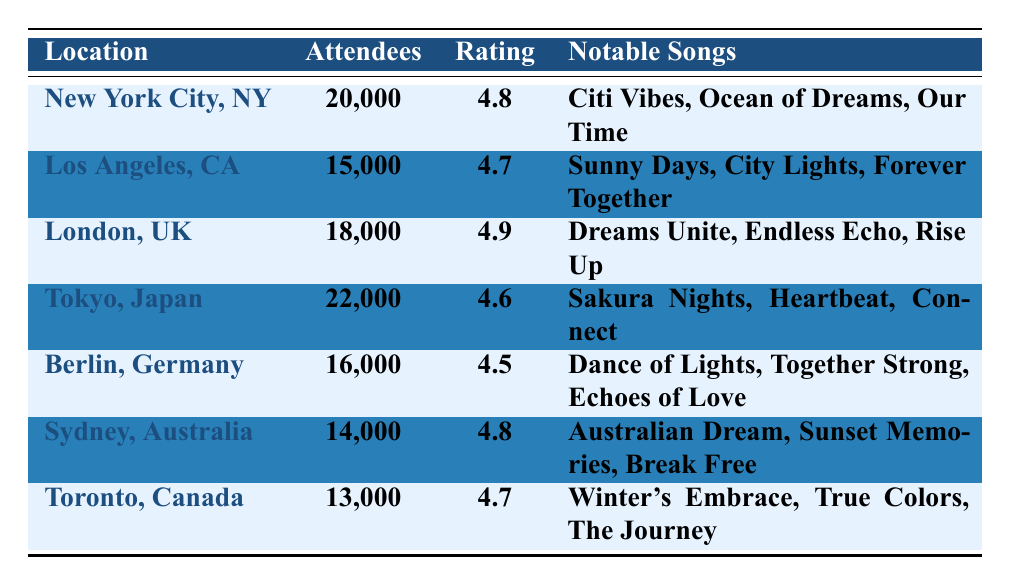What is the highest number of attendees recorded at the concerts? The concert in Tokyo, Japan had the highest number of attendees with 22,000 people.
Answer: 22,000 Which location had the lowest average rating from attendees? The concert in Berlin, Germany had the lowest average rating at 4.5.
Answer: 4.5 What is the total number of attendees across all locations? We add the attendees from each location: 20,000 + 15,000 + 18,000 + 22,000 + 16,000 + 14,000 + 13,000 = 118,000.
Answer: 118,000 Did the concert in London receive the highest average rating? No, the concert in London had a rating of 4.9, but the concert in London did not have the highest; Tokyo's average rating was 4.6 and higher than that of Berlin.
Answer: No Which notable song was performed in both New York City and Los Angeles? The notable song “City Lights” was performed in Los Angeles, while “Citi Vibes” was performed in New York City; therefore, there are no songs performed in both.
Answer: No What is the average number of attendees across all locations? We calculate the average by dividing the total number of attendees (118,000) by the number of locations (7): 118,000 / 7 = 16,857.
Answer: 16,857 How many songs were listed as notable songs for each concert location? Each concert location has exactly 3 notable songs listed.
Answer: 3 Which city's concert had a comment emphasizing "fantastic staging and fan interaction"? The comment describing "fantastic staging and fan interaction" is from the concert in Tokyo, Japan.
Answer: Tokyo, Japan What is the difference in the number of attendees between the concert in New York City and Sydney? The difference is calculated by subtracting the attendees in Sydney (14,000) from those in New York City (20,000): 20,000 - 14,000 = 6,000.
Answer: 6,000 Which city had the highest average rating and how much was it? London had the highest average rating at 4.9.
Answer: 4.9 